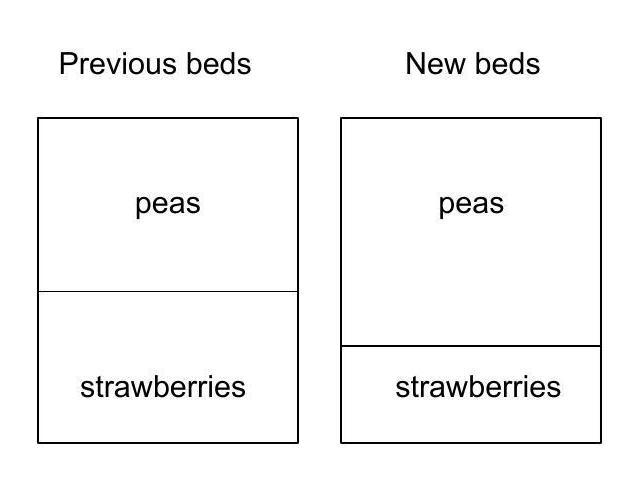Given the changes in the layout, how might the sunlight distribution affect both beds throughout the day? With the beds' new configuration, the peas in the larger, square-shaped bed may receive more consistent sunlight if the bed is oriented favorably with the path of the sun. Conversely, the strawberry bed now being smaller could mean that it shaded more easily by structures or plants around the garden, which might affect the strawberries' growth if they require full sun. Careful consideration of the garden's orientation regarding the sun's path will be vital in ensuring optimal sunlight distribution for both beds. Could the change in bed shapes lead to any differences in water retention or drainage? Absolutely. A square bed, like the new pea bed, might retain water differently compared to the original rectangular shape due to the difference in surface area to perimeter ratio. It could either facilitate more even water retention if well-designed or lead to potential waterlogging if the drainage isn't properly managed. The decreased area of the strawberry bed might alter drainage patterns as well, making the bed dry out faster, which could necessitate more frequent watering if strawberries prefer consistently moist soil. 